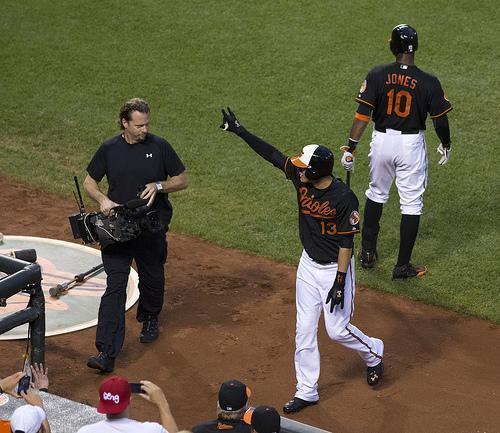How many people are holding up their camera phones?
Give a very brief answer. 2. 